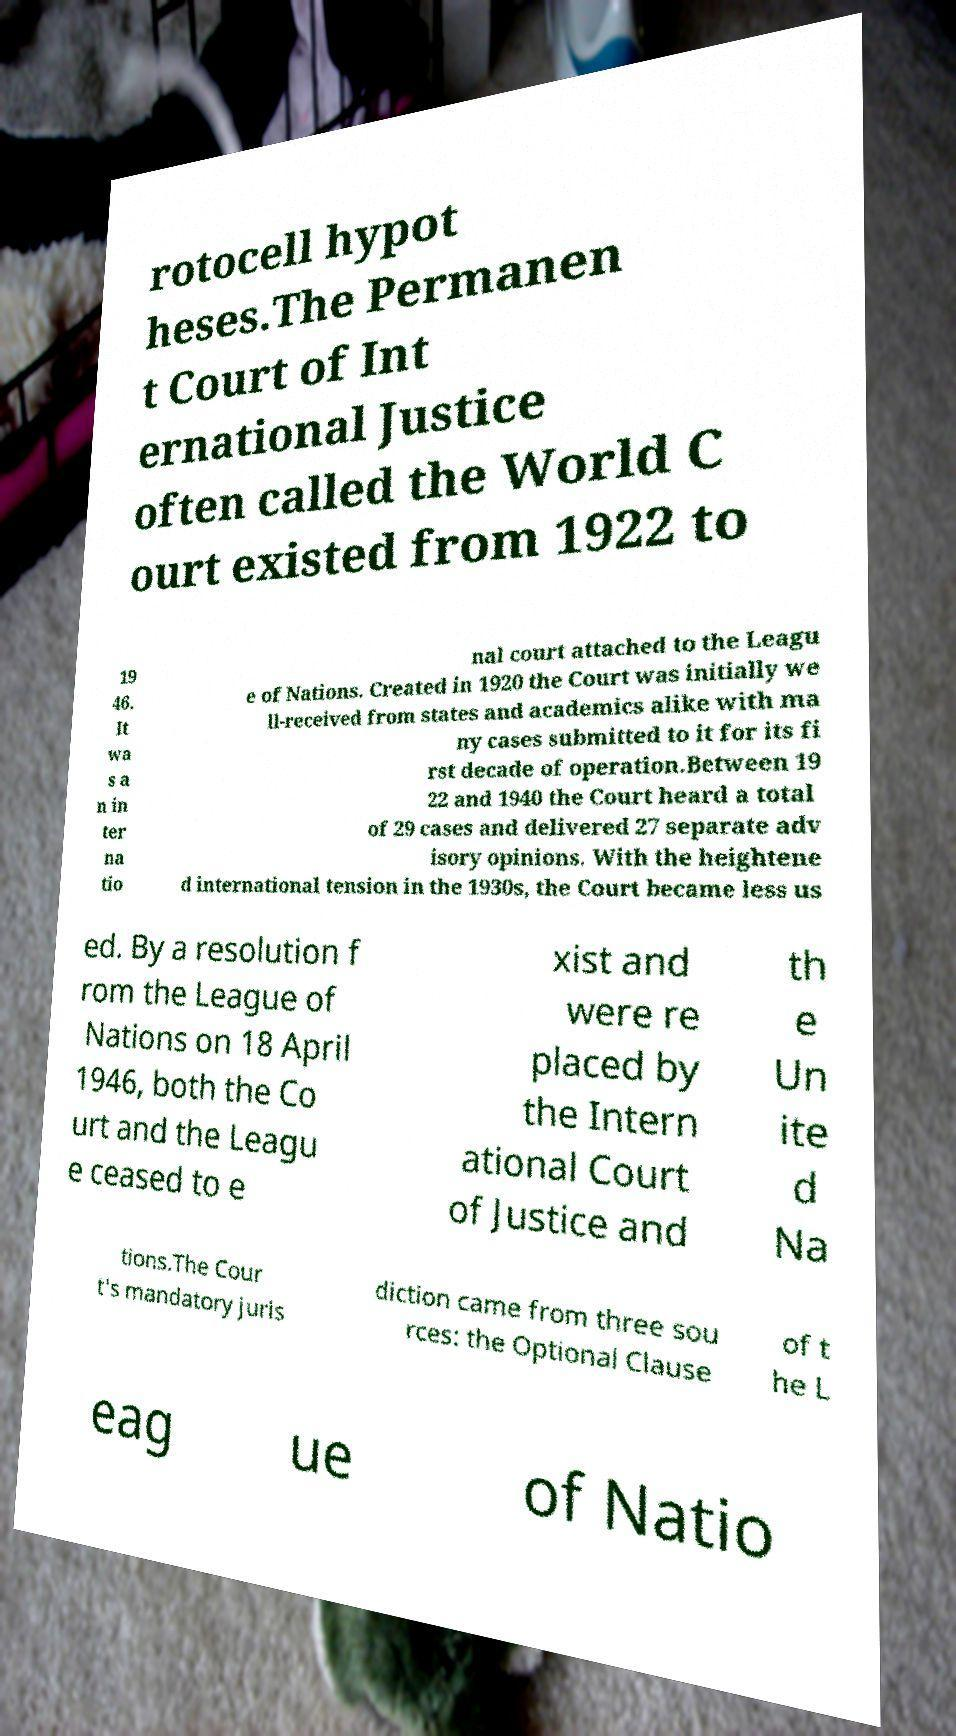There's text embedded in this image that I need extracted. Can you transcribe it verbatim? rotocell hypot heses.The Permanen t Court of Int ernational Justice often called the World C ourt existed from 1922 to 19 46. It wa s a n in ter na tio nal court attached to the Leagu e of Nations. Created in 1920 the Court was initially we ll-received from states and academics alike with ma ny cases submitted to it for its fi rst decade of operation.Between 19 22 and 1940 the Court heard a total of 29 cases and delivered 27 separate adv isory opinions. With the heightene d international tension in the 1930s, the Court became less us ed. By a resolution f rom the League of Nations on 18 April 1946, both the Co urt and the Leagu e ceased to e xist and were re placed by the Intern ational Court of Justice and th e Un ite d Na tions.The Cour t's mandatory juris diction came from three sou rces: the Optional Clause of t he L eag ue of Natio 